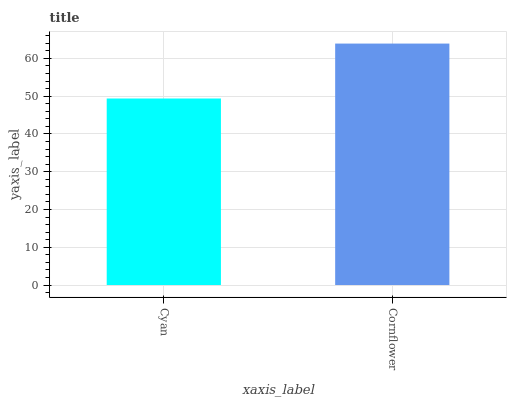Is Cyan the minimum?
Answer yes or no. Yes. Is Cornflower the maximum?
Answer yes or no. Yes. Is Cornflower the minimum?
Answer yes or no. No. Is Cornflower greater than Cyan?
Answer yes or no. Yes. Is Cyan less than Cornflower?
Answer yes or no. Yes. Is Cyan greater than Cornflower?
Answer yes or no. No. Is Cornflower less than Cyan?
Answer yes or no. No. Is Cornflower the high median?
Answer yes or no. Yes. Is Cyan the low median?
Answer yes or no. Yes. Is Cyan the high median?
Answer yes or no. No. Is Cornflower the low median?
Answer yes or no. No. 